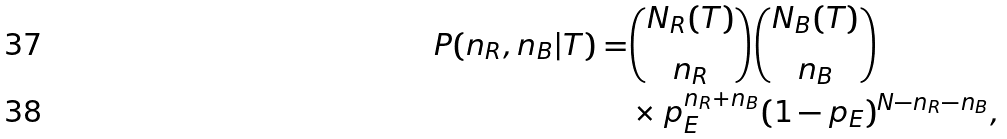Convert formula to latex. <formula><loc_0><loc_0><loc_500><loc_500>P ( n _ { R } , n _ { B } | T ) = & { N _ { R } ( T ) \choose n _ { R } } { N _ { B } ( T ) \choose n _ { B } } \\ & \times p _ { E } ^ { n _ { R } + n _ { B } } ( 1 - p _ { E } ) ^ { N - n _ { R } - n _ { B } } ,</formula> 